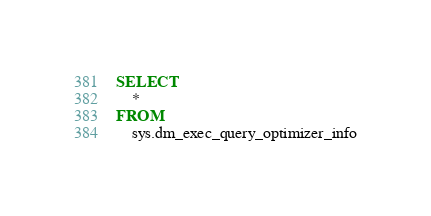Convert code to text. <code><loc_0><loc_0><loc_500><loc_500><_SQL_>SELECT
    *
FROM
    sys.dm_exec_query_optimizer_info
</code> 